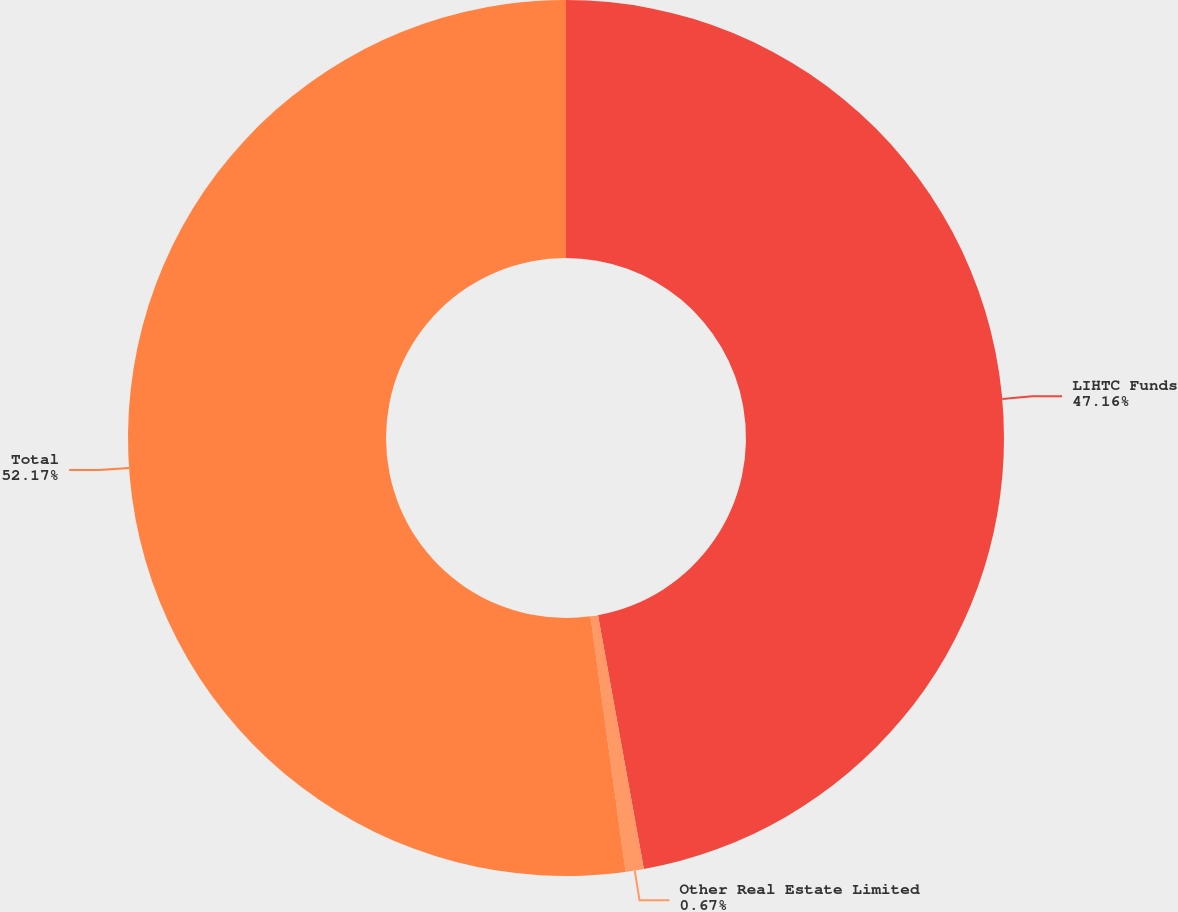<chart> <loc_0><loc_0><loc_500><loc_500><pie_chart><fcel>LIHTC Funds<fcel>Other Real Estate Limited<fcel>Total<nl><fcel>47.16%<fcel>0.67%<fcel>52.18%<nl></chart> 